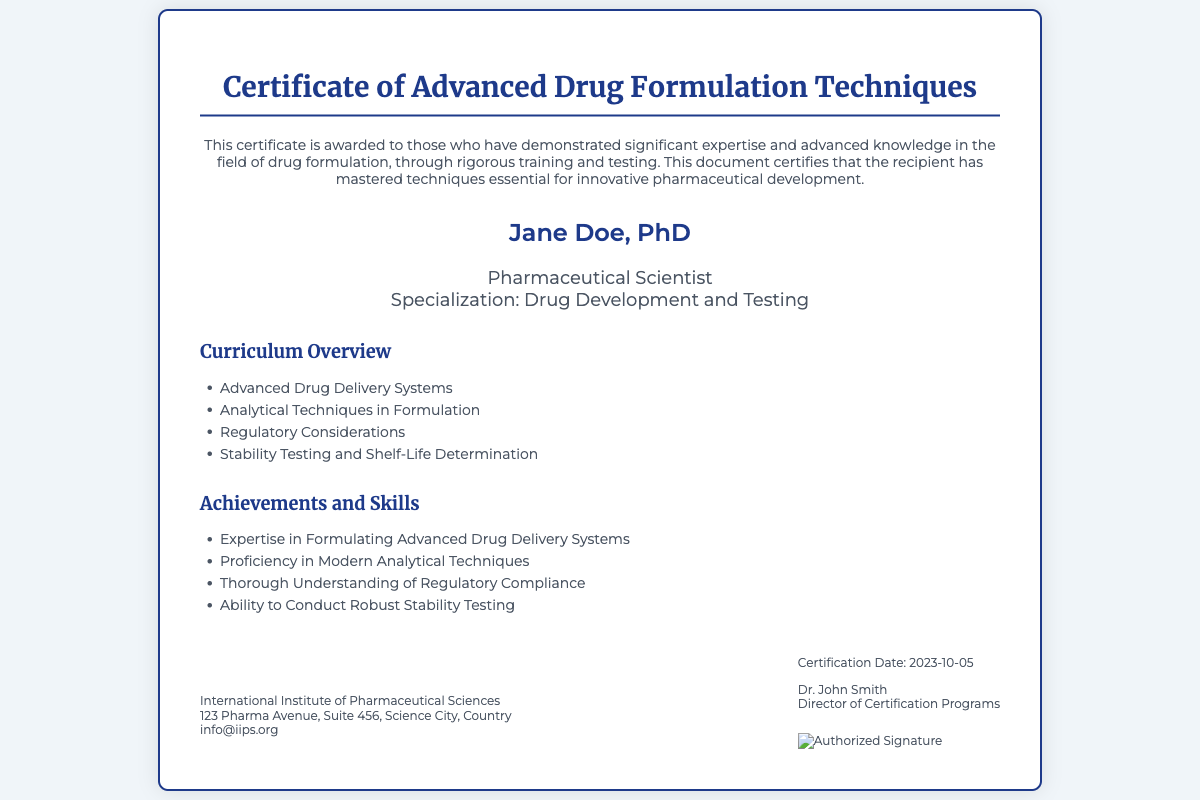what is the title of the certificate? The title of the certificate is prominently displayed at the top, indicating the subject matter of the document.
Answer: Certificate of Advanced Drug Formulation Techniques who is the recipient of this certificate? The recipient's name is stated in bold text in the center of the document.
Answer: Jane Doe, PhD what is Jane Doe's specialization? The specialization of the recipient is mentioned in the subtitle under her name.
Answer: Drug Development and Testing when was the certificate issued? The certification date is listed in the footer of the document.
Answer: 2023-10-05 who is the director of certification programs? The name of the person who signed off on the certificate is provided in the footer.
Answer: Dr. John Smith which institution issued this certificate? The certifying body is stated at the bottom of the document.
Answer: International Institute of Pharmaceutical Sciences list one subject covered in the curriculum overview. The document specifies various topics in the curriculum overview section.
Answer: Advanced Drug Delivery Systems identify one achievement mentioned in the achievements section. The achievements section lists several skills or knowledge areas gained by the recipient.
Answer: Expertise in Formulating Advanced Drug Delivery Systems what is the email address provided in the certifying body section? The email address for the institution is mentioned below the institution's name.
Answer: info@iips.org 